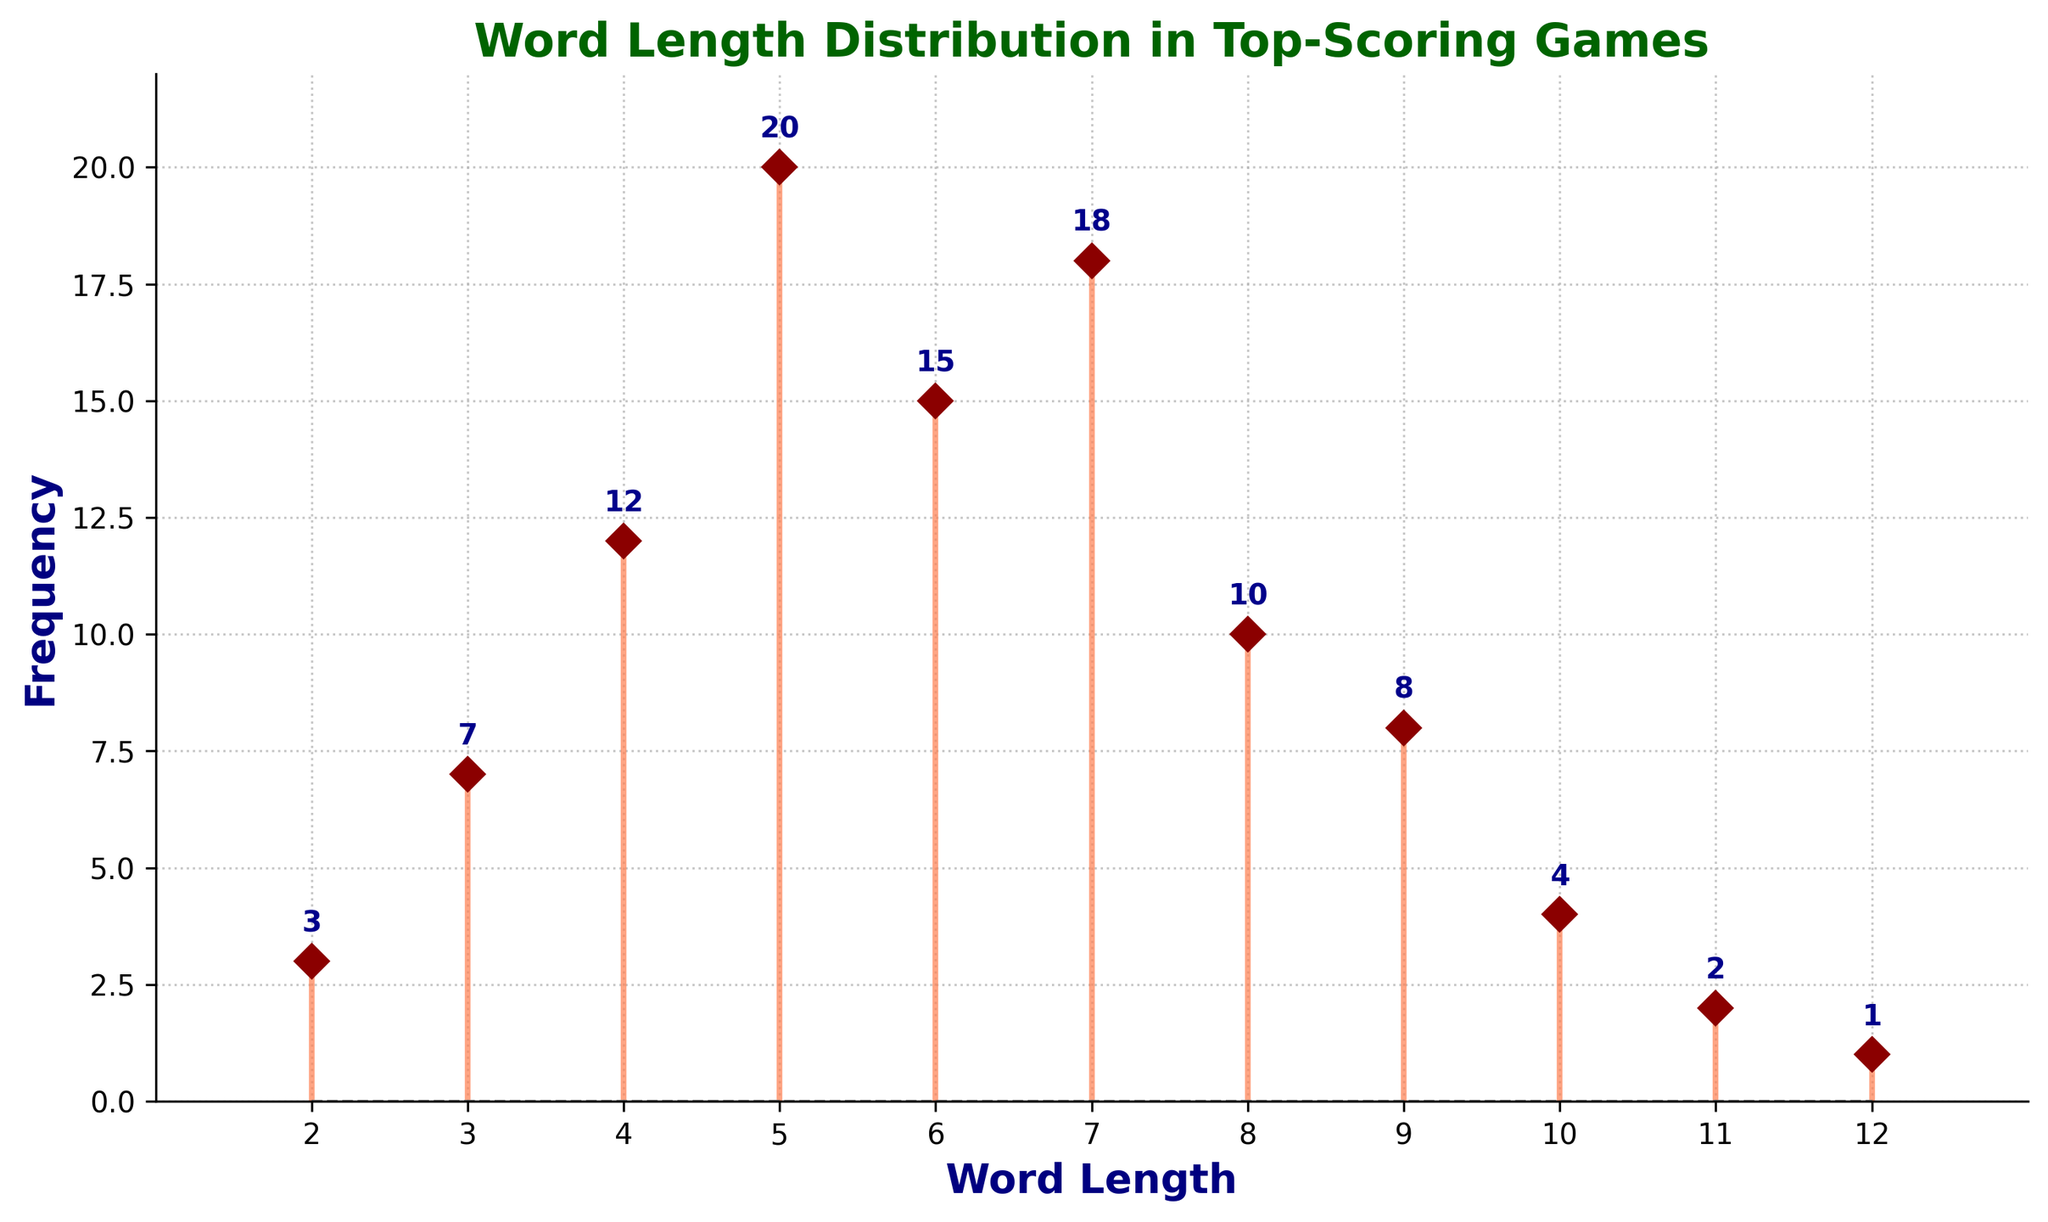What is the title of the stem plot? The title is usually displayed at the top of the figure in a larger, often bold font. In this case, the title describes the main focus of the plot.
Answer: Word Length Distribution in Top-Scoring Games What word length has the highest frequency? By looking at the height of the markers in the plot, we can see the word length with the tallest marker, which represents the highest frequency.
Answer: 5-letter words What is the lowest recorded frequency and which word length does it correspond to? The lowest points on the plot can be found by identifying the markers closest to the baseline. Here, the shortest marker corresponds to a frequency of 1.
Answer: 12-letter words How many word lengths have a frequency greater than 10? By inspecting the plot, we count the number of markers that have a value higher than 10. The markers with frequencies above this threshold are the ones of interest.
Answer: 4 What is the range of word lengths displayed in the plot? The word lengths are displayed along the x-axis. By looking at the lowest and highest values labeled on the x-axis, we can determine the range.
Answer: 2 to 12 Which word lengths have a frequency of exactly 7? We locate the marker that precisely aligns with the frequency value of 7 on the y-axis. This allows us to identify the corresponding word length.
Answer: 3-letter words What is the sum of the frequencies for word lengths of 5, 6, and 7? First, we identify the frequencies for word lengths of 5, 6, and 7, which are 20, 15, and 18 respectively. We then add these values together. 20 + 15 + 18 = 53.
Answer: 53 Are there any word lengths that share the same frequency? If so, which ones and what is the frequency? We look for markers that match in height on the plot. Here, we compare the frequencies of different word lengths to find any that are equal.
Answer: None Between word lengths of 4 and 8, which has the greater frequency? By comparing the heights of the markers for these two word lengths, we can see which frequency is greater.
Answer: 7-letter words What is the average frequency of all word lengths? We sum all the frequencies and divide by the total number of word lengths. (3 + 7 + 12 + 20 + 15 + 18 + 10 + 8 + 4 + 2 + 1) = 100. There are 11 word lengths, so the average is 100/11 ≈ 9.09.
Answer: ≈ 9.09 